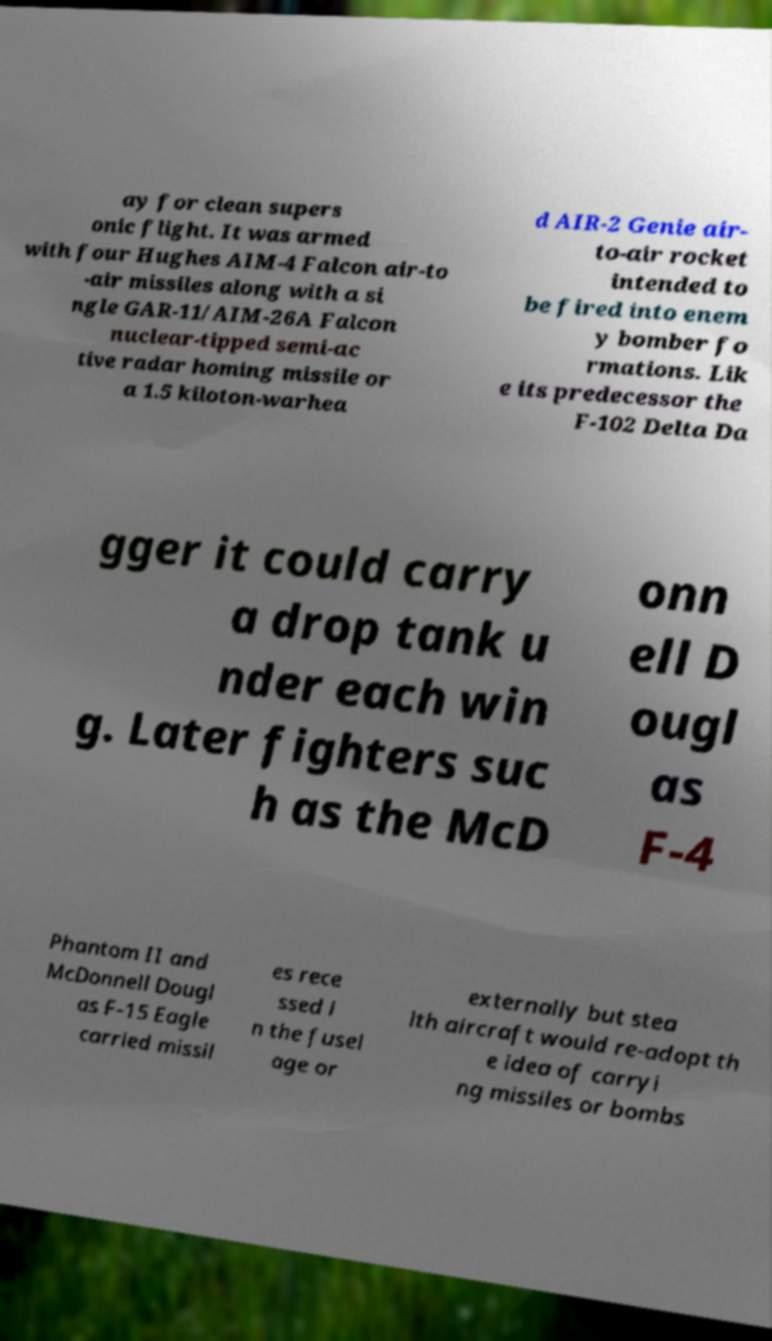For documentation purposes, I need the text within this image transcribed. Could you provide that? ay for clean supers onic flight. It was armed with four Hughes AIM-4 Falcon air-to -air missiles along with a si ngle GAR-11/AIM-26A Falcon nuclear-tipped semi-ac tive radar homing missile or a 1.5 kiloton-warhea d AIR-2 Genie air- to-air rocket intended to be fired into enem y bomber fo rmations. Lik e its predecessor the F-102 Delta Da gger it could carry a drop tank u nder each win g. Later fighters suc h as the McD onn ell D ougl as F-4 Phantom II and McDonnell Dougl as F-15 Eagle carried missil es rece ssed i n the fusel age or externally but stea lth aircraft would re-adopt th e idea of carryi ng missiles or bombs 